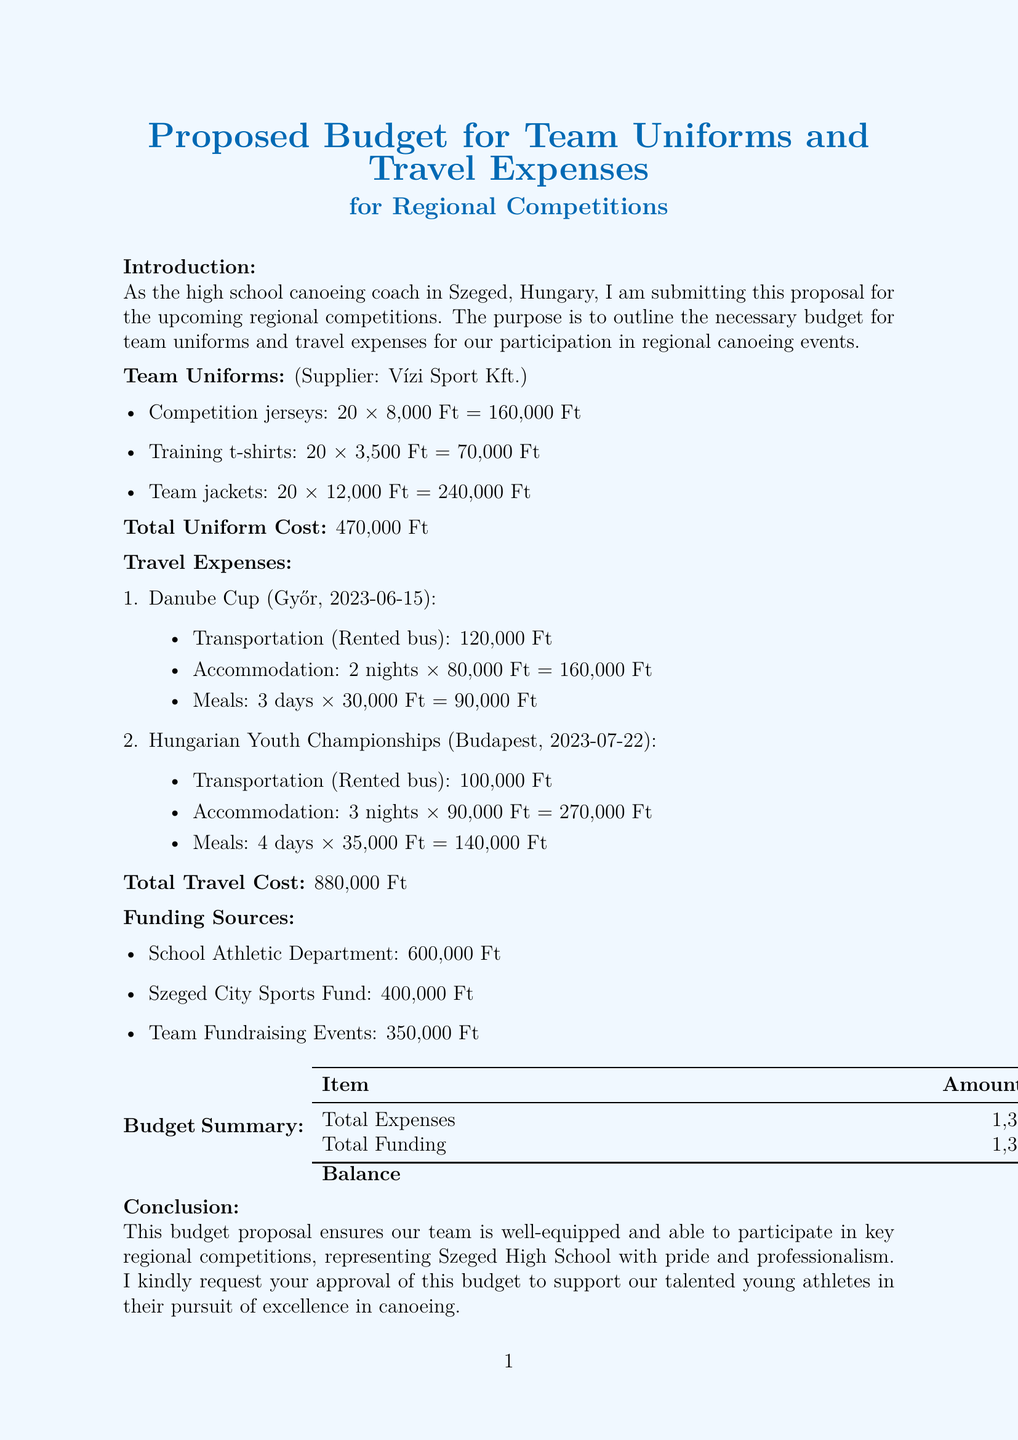what is the total cost for team uniforms? The total cost for team uniforms is explicitly stated in the document.
Answer: 470,000 Ft how many nights of accommodation are planned for the Hungarian Youth Championships? The document specifies the number of nights planned for each competition, including this one.
Answer: 3 nights what is the funding amount from the Szeged City Sports Fund? The document lists the specific funding amounts from each source, including this one.
Answer: 400,000 Ft how much is allocated for meals during the Danube Cup? The document includes a breakdown of costs, specifying the meal costs for this event.
Answer: 90,000 Ft who is the supplier of team uniforms? The memo names the supplier responsible for providing team uniforms.
Answer: Vízi Sport Kft what is the total amount requested for school athletic department funding? The document outlines various funding sources along with their amounts, including this one.
Answer: 600,000 Ft how many competition jerseys are being ordered? The document explicitly states the quantities of each uniform item being ordered.
Answer: 20 what is the location of the Danube Cup competition? The document details the location of each competition mentioned, including this one.
Answer: Győr what is the balance of the proposed budget? The budget summary in the document clearly states the balance of the proposed budget.
Answer: 0 